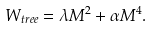Convert formula to latex. <formula><loc_0><loc_0><loc_500><loc_500>W _ { t r e e } = \lambda M ^ { 2 } + \alpha M ^ { 4 } .</formula> 